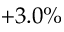Convert formula to latex. <formula><loc_0><loc_0><loc_500><loc_500>+ 3 . 0 \%</formula> 